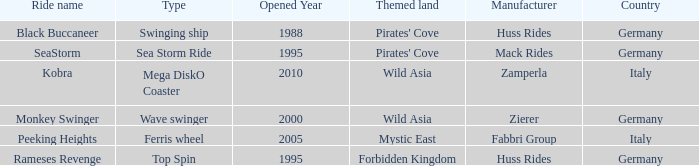What type of ride is Rameses Revenge? Top Spin. 